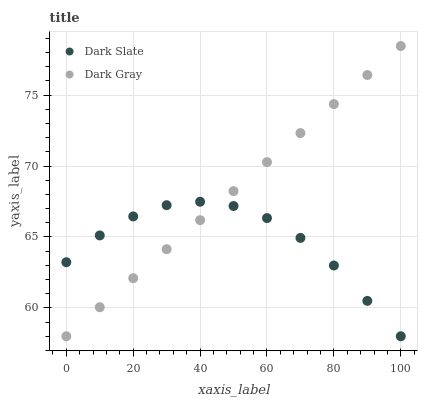Does Dark Slate have the minimum area under the curve?
Answer yes or no. Yes. Does Dark Gray have the maximum area under the curve?
Answer yes or no. Yes. Does Dark Slate have the maximum area under the curve?
Answer yes or no. No. Is Dark Gray the smoothest?
Answer yes or no. Yes. Is Dark Slate the roughest?
Answer yes or no. Yes. Is Dark Slate the smoothest?
Answer yes or no. No. Does Dark Gray have the lowest value?
Answer yes or no. Yes. Does Dark Gray have the highest value?
Answer yes or no. Yes. Does Dark Slate have the highest value?
Answer yes or no. No. Does Dark Gray intersect Dark Slate?
Answer yes or no. Yes. Is Dark Gray less than Dark Slate?
Answer yes or no. No. Is Dark Gray greater than Dark Slate?
Answer yes or no. No. 